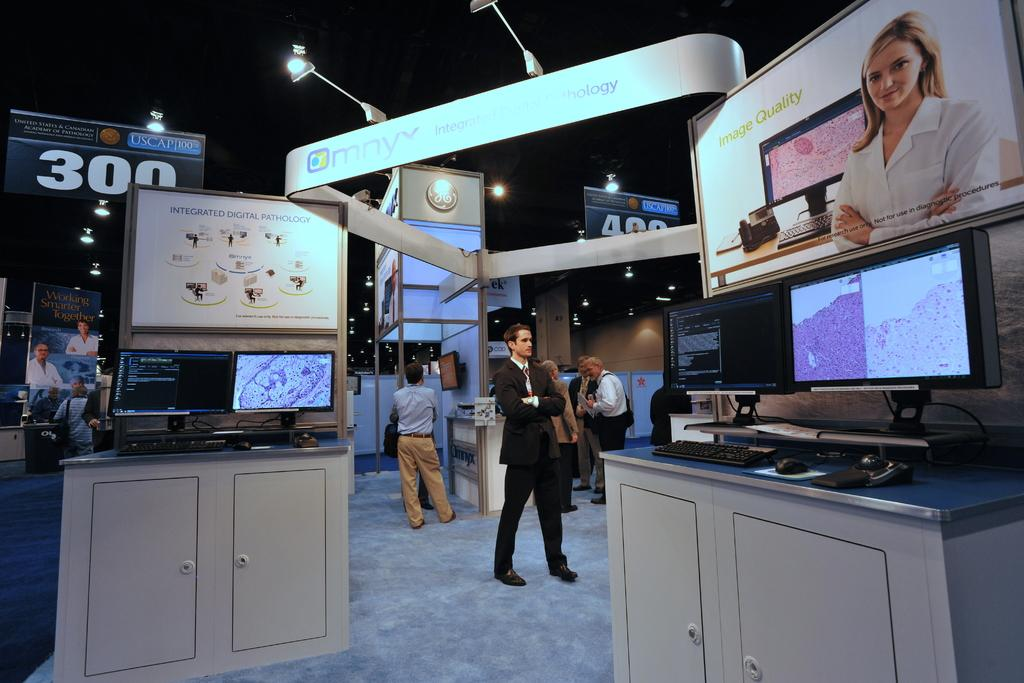<image>
Offer a succinct explanation of the picture presented. A banner at an event advertises "integrated digital pathology." 